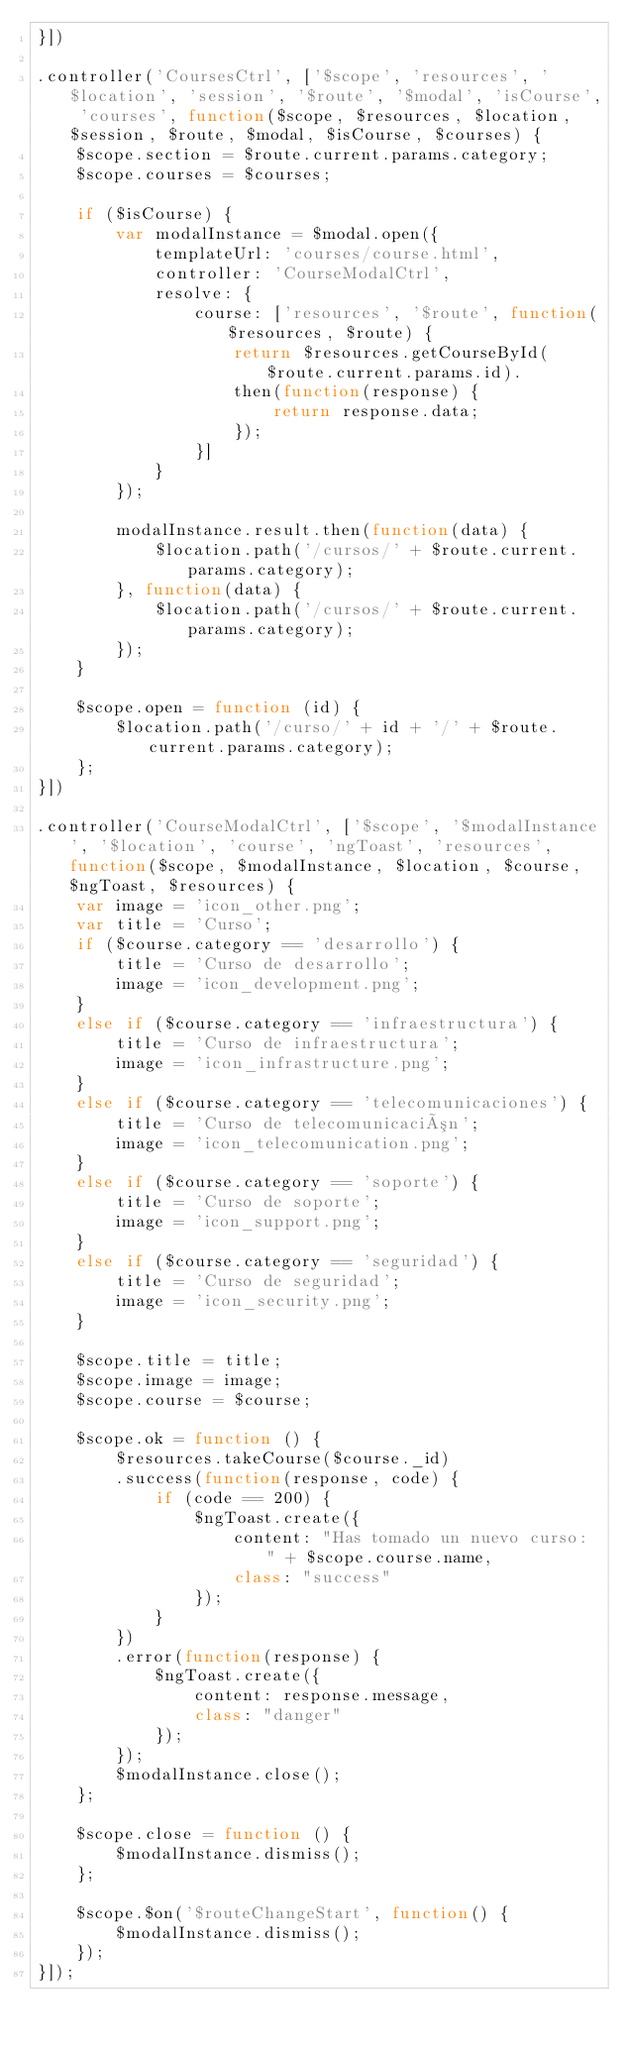<code> <loc_0><loc_0><loc_500><loc_500><_JavaScript_>}])

.controller('CoursesCtrl', ['$scope', 'resources', '$location', 'session', '$route', '$modal', 'isCourse', 'courses', function($scope, $resources, $location, $session, $route, $modal, $isCourse, $courses) {
    $scope.section = $route.current.params.category;
    $scope.courses = $courses;

    if ($isCourse) {
        var modalInstance = $modal.open({
            templateUrl: 'courses/course.html',
            controller: 'CourseModalCtrl',
            resolve: {
                course: ['resources', '$route', function($resources, $route) {
                    return $resources.getCourseById($route.current.params.id).
                    then(function(response) {
                        return response.data;
                    });
                }]
            }
        });

        modalInstance.result.then(function(data) {
            $location.path('/cursos/' + $route.current.params.category);
        }, function(data) {
            $location.path('/cursos/' + $route.current.params.category);
        });
    }

    $scope.open = function (id) {
        $location.path('/curso/' + id + '/' + $route.current.params.category);
    };
}])

.controller('CourseModalCtrl', ['$scope', '$modalInstance', '$location', 'course', 'ngToast', 'resources', function($scope, $modalInstance, $location, $course, $ngToast, $resources) {
    var image = 'icon_other.png';
    var title = 'Curso';
    if ($course.category == 'desarrollo') {
        title = 'Curso de desarrollo';
        image = 'icon_development.png';
    }
    else if ($course.category == 'infraestructura') {
        title = 'Curso de infraestructura';
        image = 'icon_infrastructure.png';
    }
    else if ($course.category == 'telecomunicaciones') {
        title = 'Curso de telecomunicación';
        image = 'icon_telecomunication.png';
    }
    else if ($course.category == 'soporte') {
        title = 'Curso de soporte';
        image = 'icon_support.png';
    }
    else if ($course.category == 'seguridad') {
        title = 'Curso de seguridad';
        image = 'icon_security.png';
    }

    $scope.title = title;
    $scope.image = image;
    $scope.course = $course;

    $scope.ok = function () {
        $resources.takeCourse($course._id)
        .success(function(response, code) {
            if (code == 200) {
                $ngToast.create({
                    content: "Has tomado un nuevo curso: " + $scope.course.name,
                    class: "success"
                });
            }
        })
        .error(function(response) {
            $ngToast.create({
                content: response.message,
                class: "danger"
            });
        });
        $modalInstance.close();
    };

    $scope.close = function () {
        $modalInstance.dismiss();
    };

    $scope.$on('$routeChangeStart', function() {
        $modalInstance.dismiss();
    });
}]);
</code> 